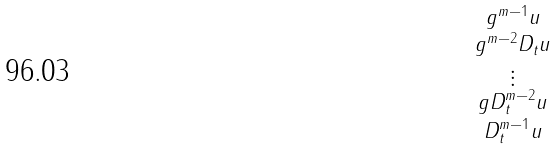Convert formula to latex. <formula><loc_0><loc_0><loc_500><loc_500>\begin{smallmatrix} g ^ { m - 1 } u \\ g ^ { m - 2 } D _ { t } u \\ \vdots \\ g D _ { t } ^ { m - 2 } u \\ D _ { t } ^ { m - 1 } u \end{smallmatrix}</formula> 